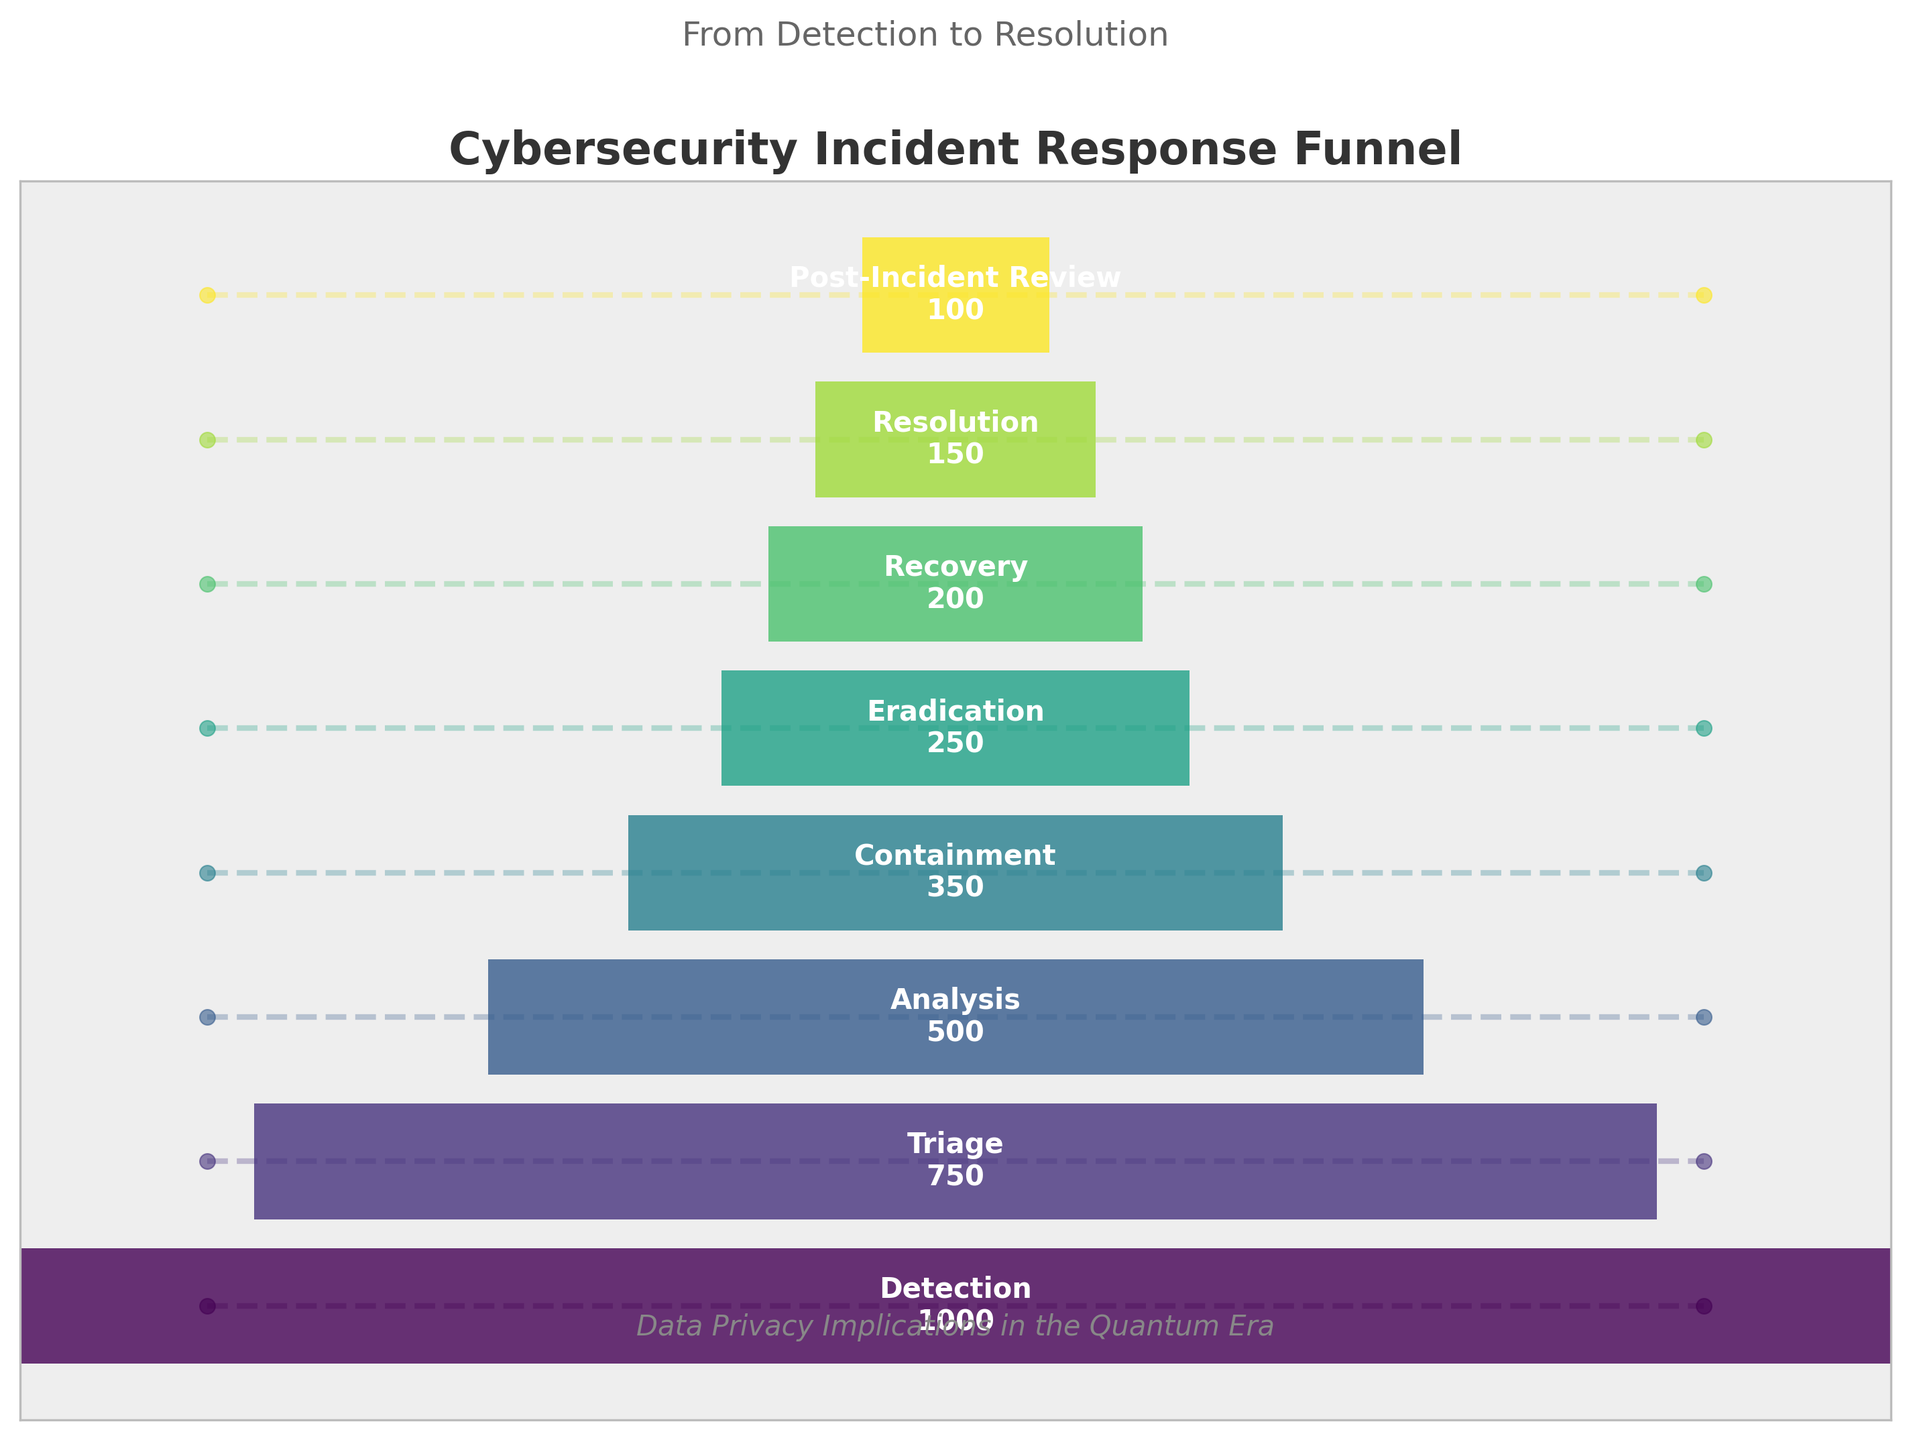what is the title of the plot? The title is often found at the top of the chart and provides a brief description of what the chart represents. In this case, it reads "Cybersecurity Incident Response Funnel".
Answer: Cybersecurity Incident Response Funnel What stage has the highest number of incidents? The stage with the highest number of incidents is the one with the widest bar on the left side of the funnel. The label on the bar shows "Detection" with 1000 incidents.
Answer: Detection How many incidents are there at the Recovery stage? To find the number of incidents in the Recovery stage, locate the bar labeled "Recovery" and read the number, which is written as 200.
Answer: 200 Which stage follows Containment, and how many incidents does it have? Following the sequence from top to bottom, the stage after Containment is Eradication. The number of incidents in this stage, as labeled on the bar, is 250.
Answer: Eradication, 250 How many stages have fewer than 300 incidents? Count the stages where the number of incidents is less than 300. These stages are Eradication (250), Recovery (200), Resolution (150), and Post-Incident Review (100), making a total of 4 stages.
Answer: 4 What is the decrease in incidents from Analysis to Containment? To find the decrease, subtract the number of incidents in Containment from that in Analysis. Analysis has 500 incidents, and Containment has 350. So, the decrease is 500 - 350 = 150.
Answer: 150 How does the width of the bar change from Detection to Resolution? The width of the bars decreases as the number of incidents reduces stage by stage. Detection starts with the widest bar, narrowing down to Resolution.
Answer: Decreases What is the average number of incidents across all stages? Add the number of incidents from all stages and divide by the number of stages. The total is (1000 + 750 + 500 + 350 + 250 + 200 + 150 + 100) = 3300. There are 8 stages, so the average is 3300 / 8 = 412.5.
Answer: 412.5 Compare the number of incidents in Triage and Post-Incident Review. What is the ratio of Triage to Post-Incident Review? To find the ratio, divide the number of incidents in Triage (750) by the number in Post-Incident Review (100). The ratio is 750 / 100 = 7.5.
Answer: 7.5 What is the reduction in incidents from Recovery to Resolution as a percentage of the incidents in Recovery? Calculate the reduction, which is Recovery (200) - Resolution (150) = 50. Then find the percentage: (50 / 200) * 100 = 25%.
Answer: 25% 